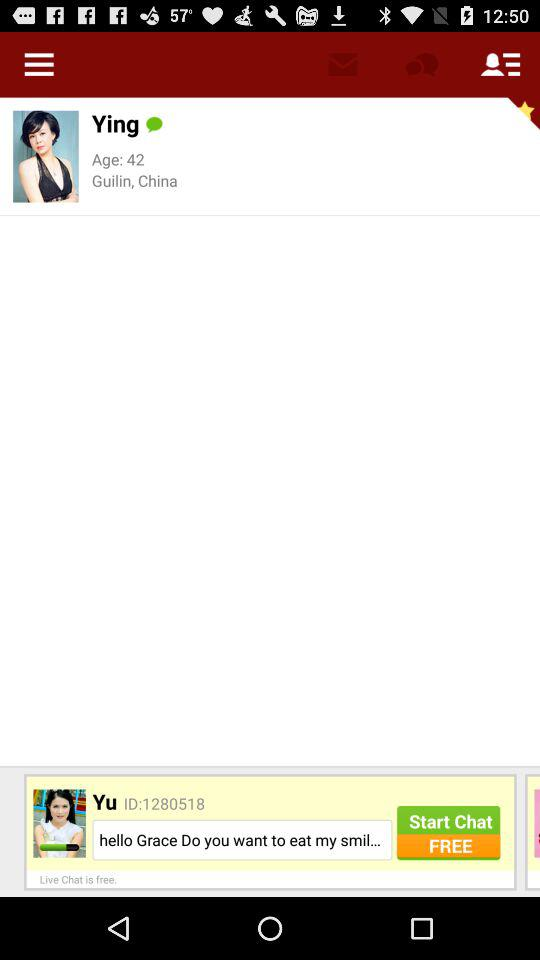How many people are in this chat?
Answer the question using a single word or phrase. 2 